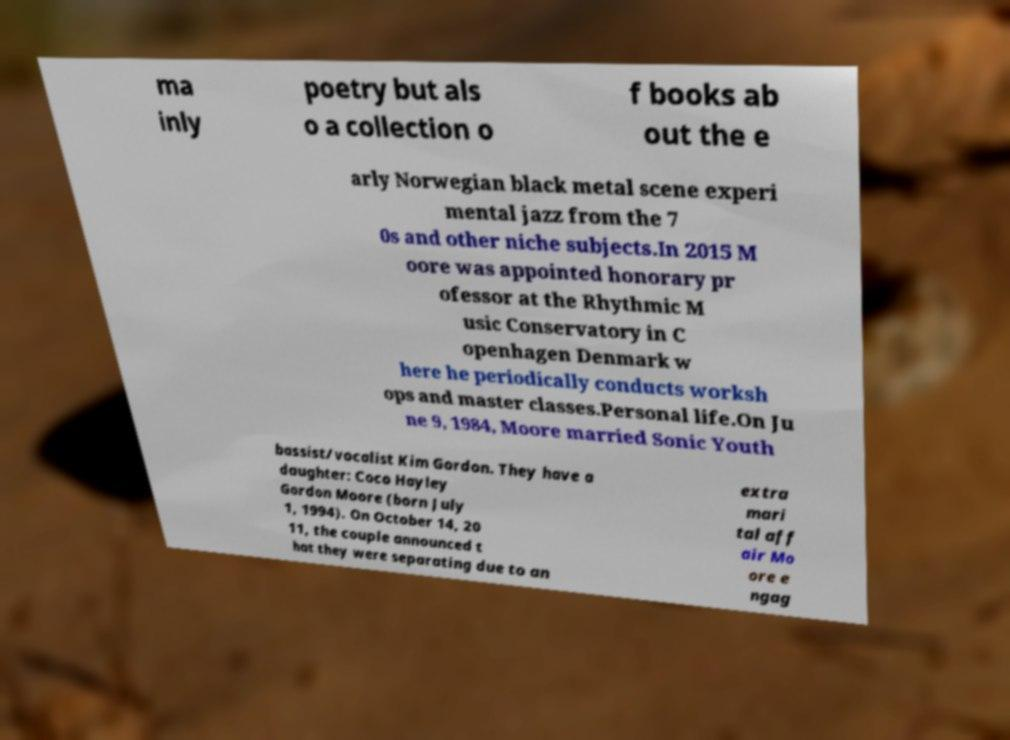Please read and relay the text visible in this image. What does it say? ma inly poetry but als o a collection o f books ab out the e arly Norwegian black metal scene experi mental jazz from the 7 0s and other niche subjects.In 2015 M oore was appointed honorary pr ofessor at the Rhythmic M usic Conservatory in C openhagen Denmark w here he periodically conducts worksh ops and master classes.Personal life.On Ju ne 9, 1984, Moore married Sonic Youth bassist/vocalist Kim Gordon. They have a daughter: Coco Hayley Gordon Moore (born July 1, 1994). On October 14, 20 11, the couple announced t hat they were separating due to an extra mari tal aff air Mo ore e ngag 